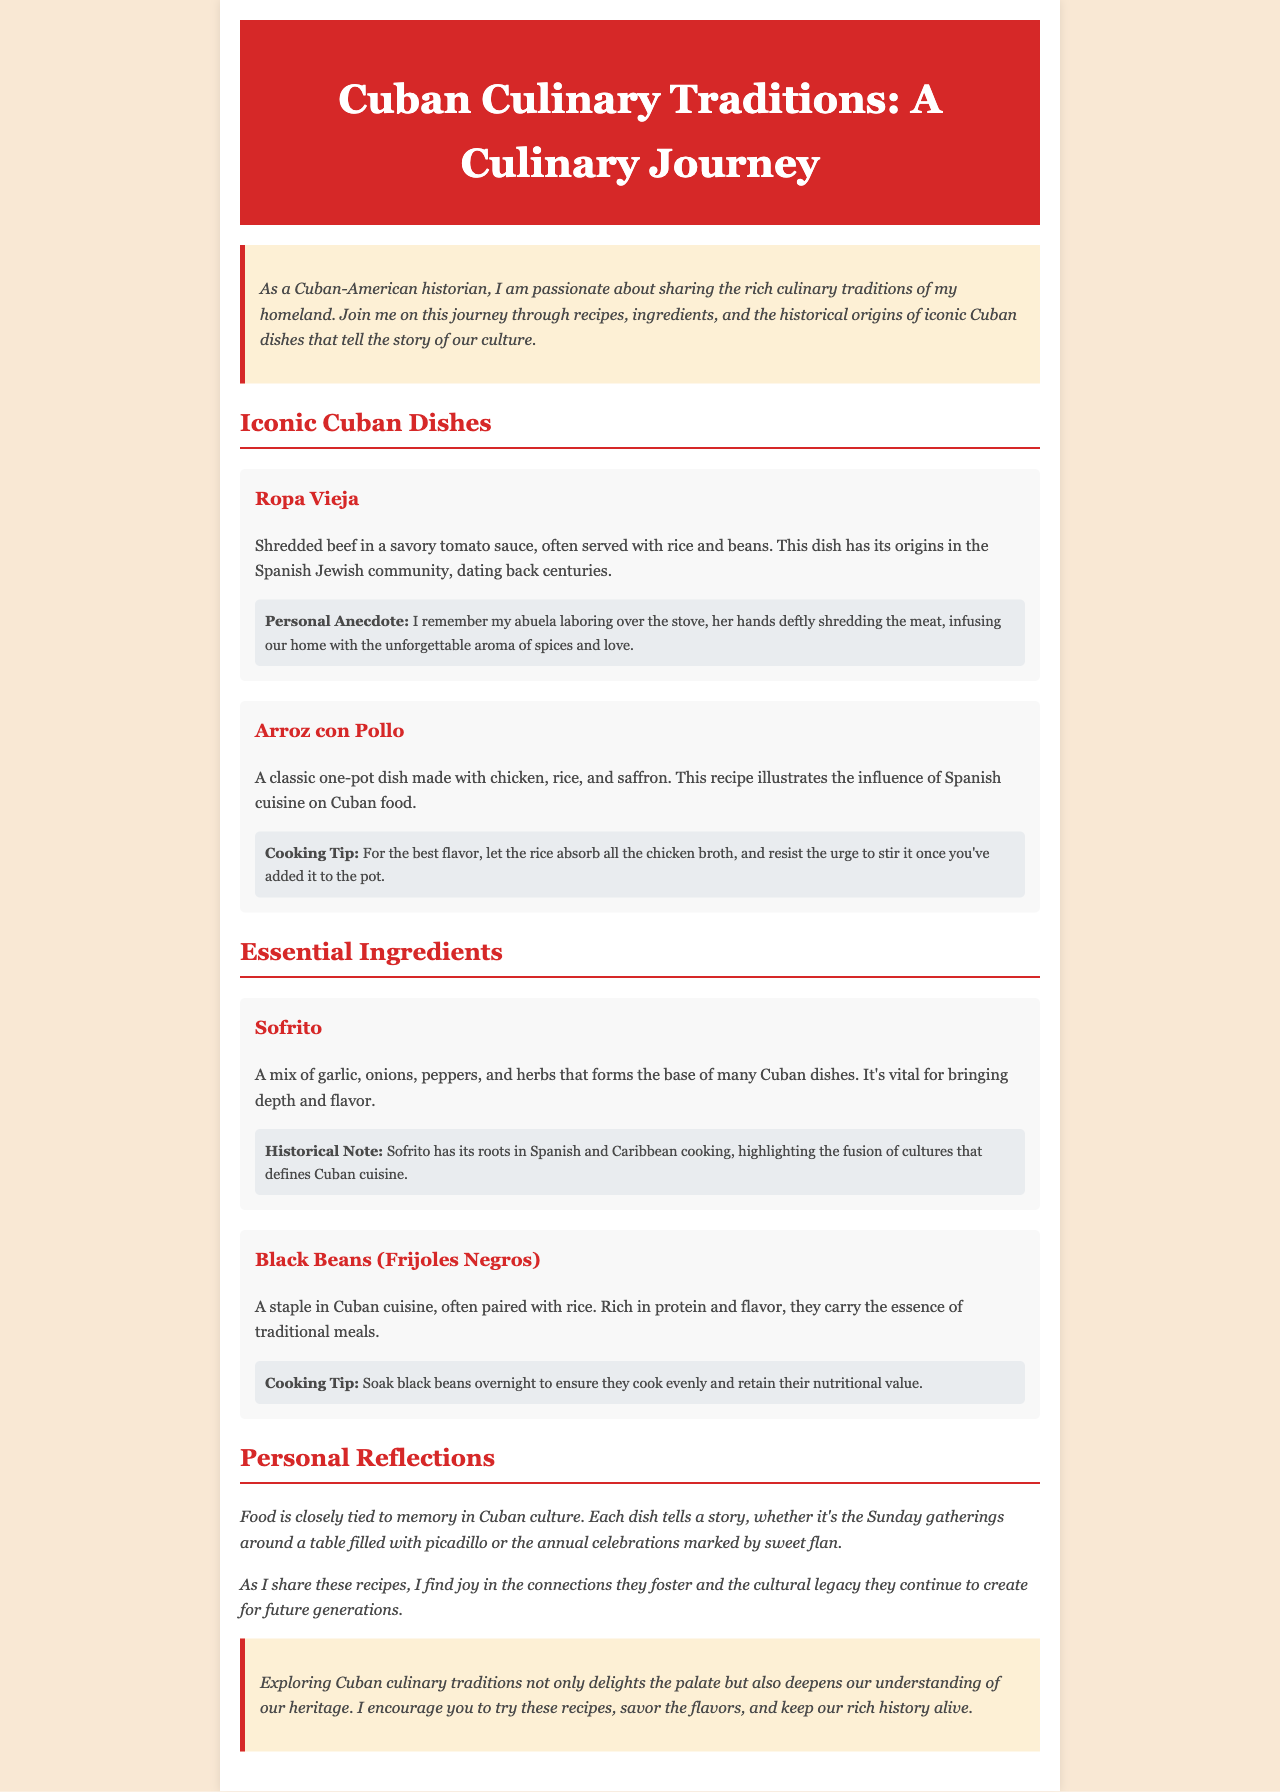what is the title of the document? The title is prominently displayed in the header section of the newsletter.
Answer: Cuban Culinary Traditions: A Culinary Journey who is mentioned as the author of the newsletter? The author is mentioned in the introductory section where they share their passion.
Answer: A Cuban-American historian what is the main ingredient in Ropa Vieja? The dish description mentions its primary component.
Answer: Shredded beef what is a key cooking tip for Arroz con Pollo? The cooking tip is given in the relevant dish section.
Answer: Resist the urge to stir it what does Sofrito consist of? The ingredient description specifies the components of Sofrito.
Answer: Garlic, onions, peppers, and herbs what historical influence is noted for Black Beans? The historical note section provides context on the cultural background of the ingredient.
Answer: Traditional meals how is food tied to memory in Cuban culture? The reflection sections discuss the connection between food and personal memories.
Answer: Each dish tells a story what type of cooking style does the newsletter emphasize? The overall narrative throughout the document focuses on a specific approach to food preparation.
Answer: Traditional Cuban cuisine 